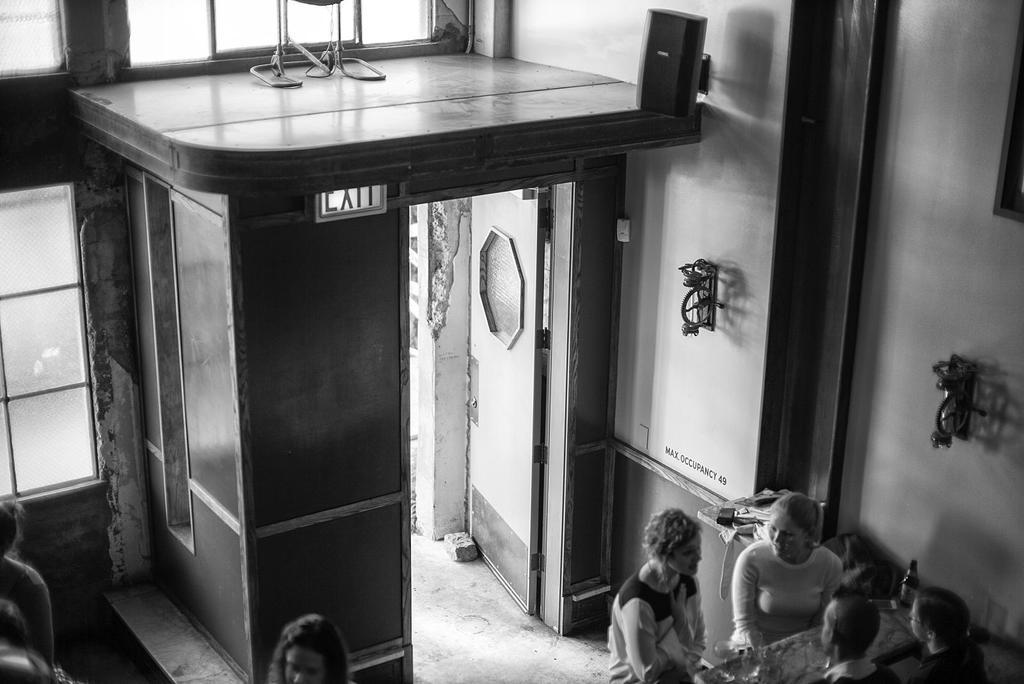What are the people in the image doing? The people in the image are sitting on chairs in the room. Where are the people located in the room? The people are at a table in the room. What items can be seen on the table? There are glasses and wine bottles on the table. What can be seen in the background of the room? There are windows, a wall, a door, and lights in the background of the room. What type of sponge is being used for comparison in the image? There is no sponge present in the image, and no comparison is being made. What type of trade is being conducted in the image? There is no trade being conducted in the image; the people are sitting at a table with glasses and wine bottles. 